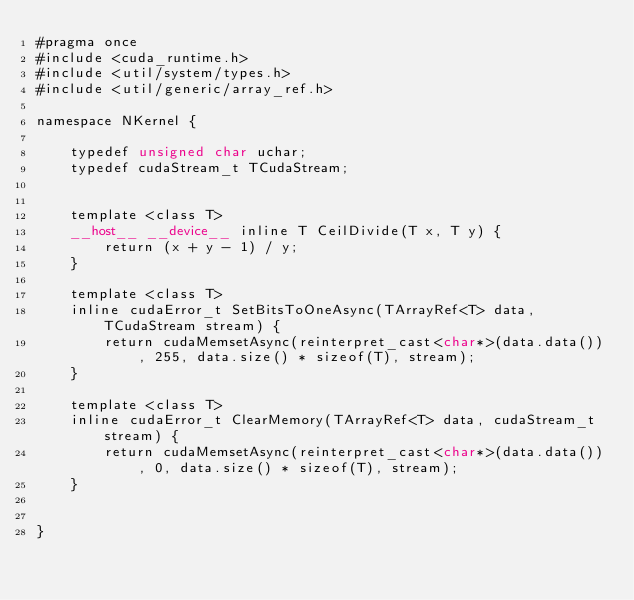<code> <loc_0><loc_0><loc_500><loc_500><_Cuda_>#pragma once
#include <cuda_runtime.h>
#include <util/system/types.h>
#include <util/generic/array_ref.h>

namespace NKernel {

    typedef unsigned char uchar;
    typedef cudaStream_t TCudaStream;


    template <class T>
    __host__ __device__ inline T CeilDivide(T x, T y) {
        return (x + y - 1) / y;
    }

    template <class T>
    inline cudaError_t SetBitsToOneAsync(TArrayRef<T> data, TCudaStream stream) {
        return cudaMemsetAsync(reinterpret_cast<char*>(data.data()), 255, data.size() * sizeof(T), stream);
    }

    template <class T>
    inline cudaError_t ClearMemory(TArrayRef<T> data, cudaStream_t stream) {
        return cudaMemsetAsync(reinterpret_cast<char*>(data.data()), 0, data.size() * sizeof(T), stream);
    }


}
</code> 